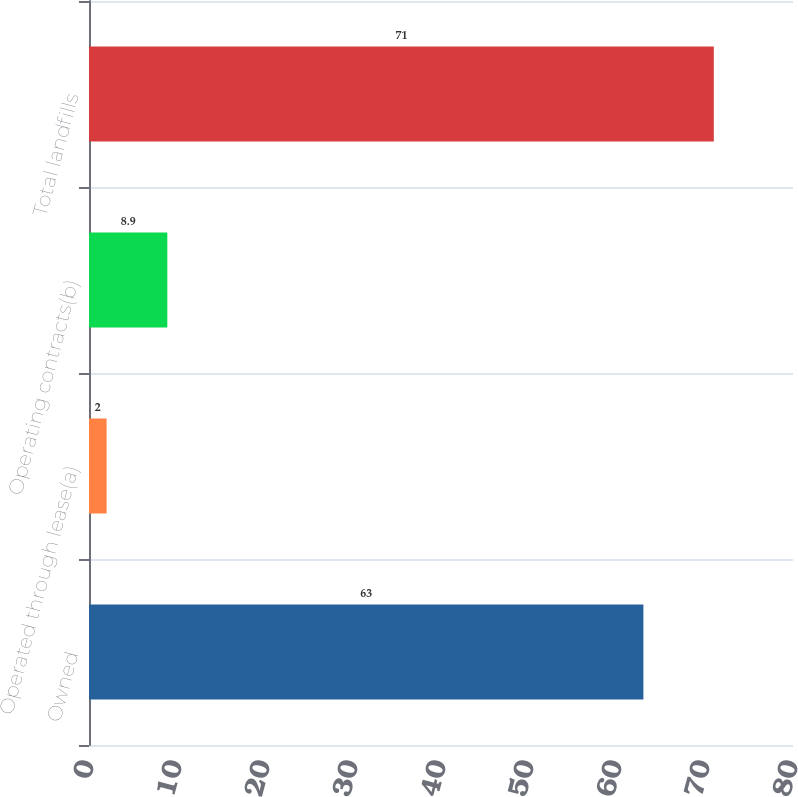Convert chart. <chart><loc_0><loc_0><loc_500><loc_500><bar_chart><fcel>Owned<fcel>Operated through lease(a)<fcel>Operating contracts(b)<fcel>Total landfills<nl><fcel>63<fcel>2<fcel>8.9<fcel>71<nl></chart> 